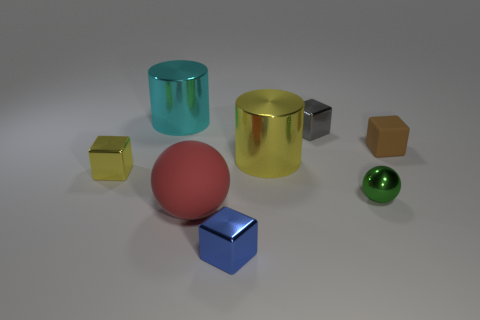Subtract all brown matte cubes. How many cubes are left? 3 Add 1 red things. How many objects exist? 9 Subtract all yellow cylinders. How many cylinders are left? 1 Subtract all tiny green spheres. Subtract all large metal cylinders. How many objects are left? 5 Add 4 matte cubes. How many matte cubes are left? 5 Add 5 small metal balls. How many small metal balls exist? 6 Subtract 1 green balls. How many objects are left? 7 Subtract all spheres. How many objects are left? 6 Subtract all purple blocks. Subtract all blue spheres. How many blocks are left? 4 